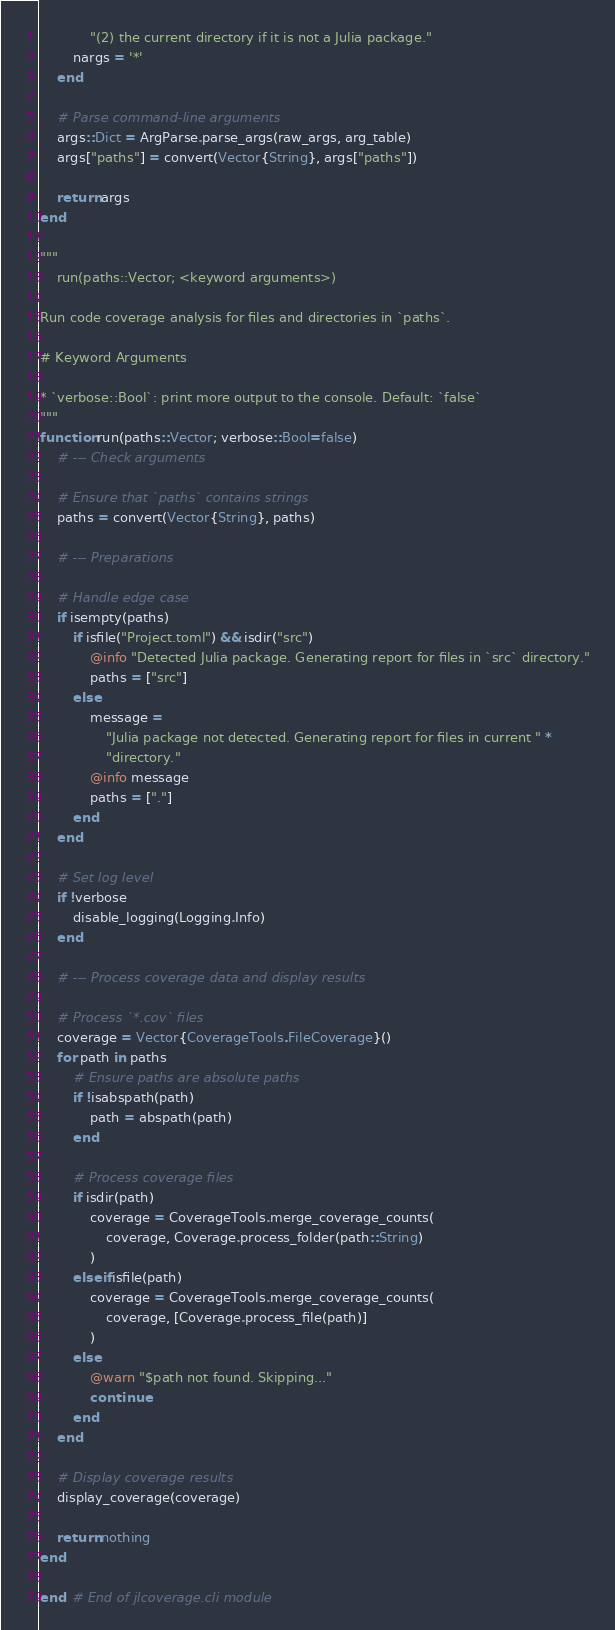Convert code to text. <code><loc_0><loc_0><loc_500><loc_500><_Julia_>            "(2) the current directory if it is not a Julia package."
        nargs = '*'
    end

    # Parse command-line arguments
    args::Dict = ArgParse.parse_args(raw_args, arg_table)
    args["paths"] = convert(Vector{String}, args["paths"])

    return args
end

"""
    run(paths::Vector; <keyword arguments>)

Run code coverage analysis for files and directories in `paths`.

# Keyword Arguments

* `verbose::Bool`: print more output to the console. Default: `false`
"""
function run(paths::Vector; verbose::Bool=false)
    # --- Check arguments

    # Ensure that `paths` contains strings
    paths = convert(Vector{String}, paths)

    # --- Preparations

    # Handle edge case
    if isempty(paths)
        if isfile("Project.toml") && isdir("src")
            @info "Detected Julia package. Generating report for files in `src` directory."
            paths = ["src"]
        else
            message =
                "Julia package not detected. Generating report for files in current " *
                "directory."
            @info message
            paths = ["."]
        end
    end

    # Set log level
    if !verbose
        disable_logging(Logging.Info)
    end

    # --- Process coverage data and display results

    # Process `*.cov` files
    coverage = Vector{CoverageTools.FileCoverage}()
    for path in paths
        # Ensure paths are absolute paths
        if !isabspath(path)
            path = abspath(path)
        end

        # Process coverage files
        if isdir(path)
            coverage = CoverageTools.merge_coverage_counts(
                coverage, Coverage.process_folder(path::String)
            )
        elseif isfile(path)
            coverage = CoverageTools.merge_coverage_counts(
                coverage, [Coverage.process_file(path)]
            )
        else
            @warn "$path not found. Skipping..."
            continue
        end
    end

    # Display coverage results
    display_coverage(coverage)

    return nothing
end

end  # End of jlcoverage.cli module
</code> 